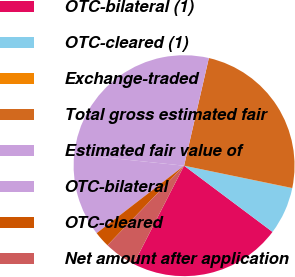Convert chart. <chart><loc_0><loc_0><loc_500><loc_500><pie_chart><fcel>OTC-bilateral (1)<fcel>OTC-cleared (1)<fcel>Exchange-traded<fcel>Total gross estimated fair<fcel>Estimated fair value of<fcel>OTC-bilateral<fcel>OTC-cleared<fcel>Net amount after application<nl><fcel>22.32%<fcel>6.96%<fcel>0.03%<fcel>24.64%<fcel>26.95%<fcel>12.11%<fcel>2.34%<fcel>4.65%<nl></chart> 